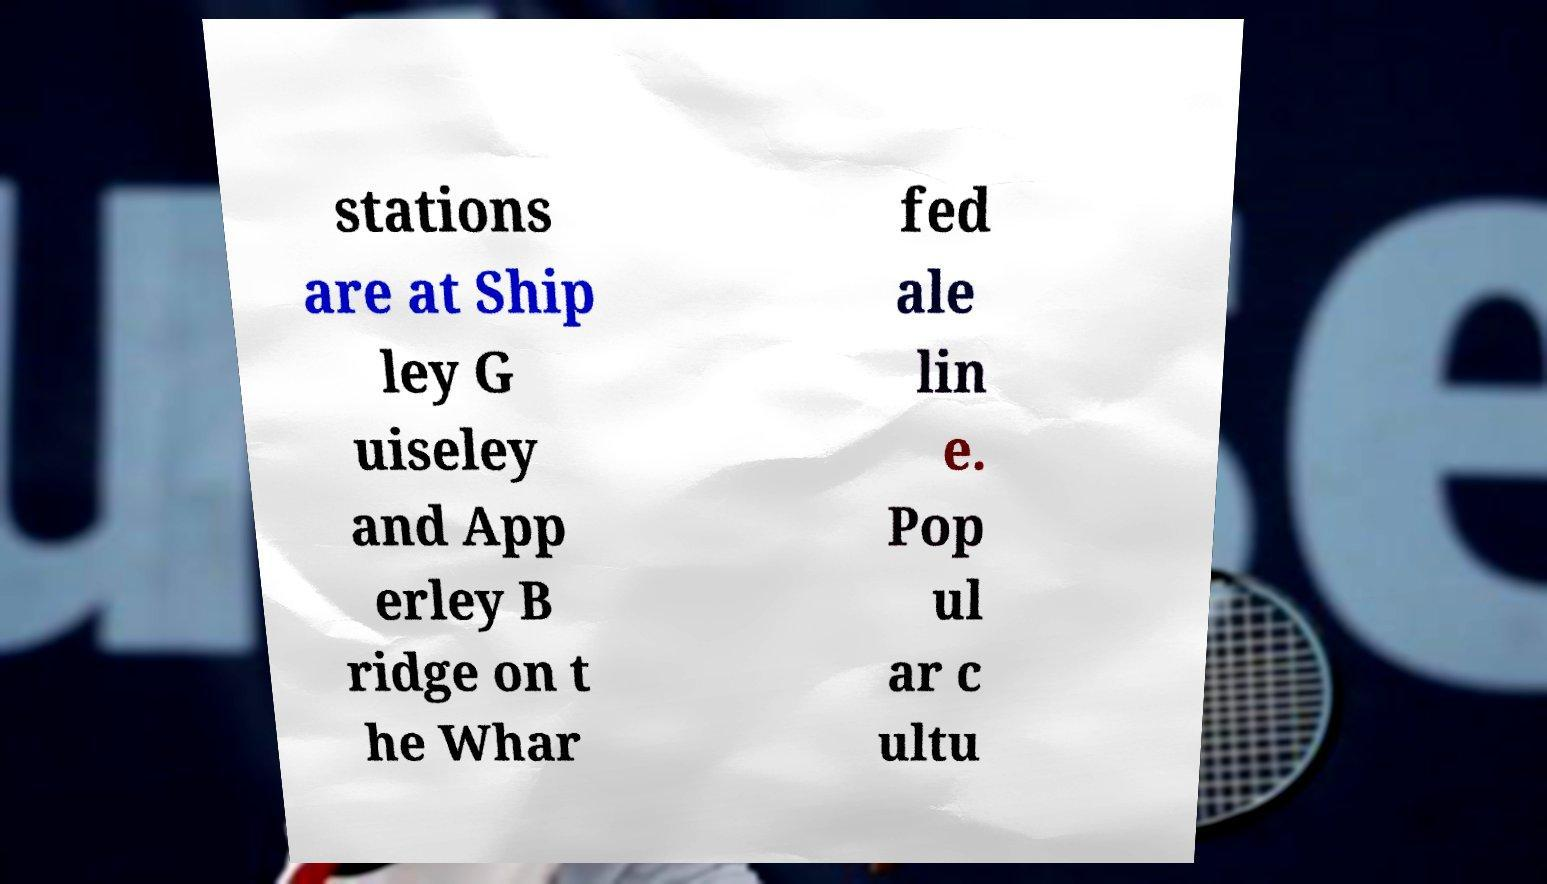Could you extract and type out the text from this image? stations are at Ship ley G uiseley and App erley B ridge on t he Whar fed ale lin e. Pop ul ar c ultu 